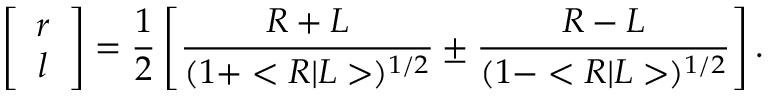<formula> <loc_0><loc_0><loc_500><loc_500>\left [ \begin{array} { c } { r } \\ { l } \end{array} \right ] = \frac { 1 } { 2 } \left [ \frac { R + L } { ( 1 + < R | L > ) ^ { 1 / 2 } } \pm \frac { R - L } { ( 1 - < R | L > ) ^ { 1 / 2 } } \right ] .</formula> 